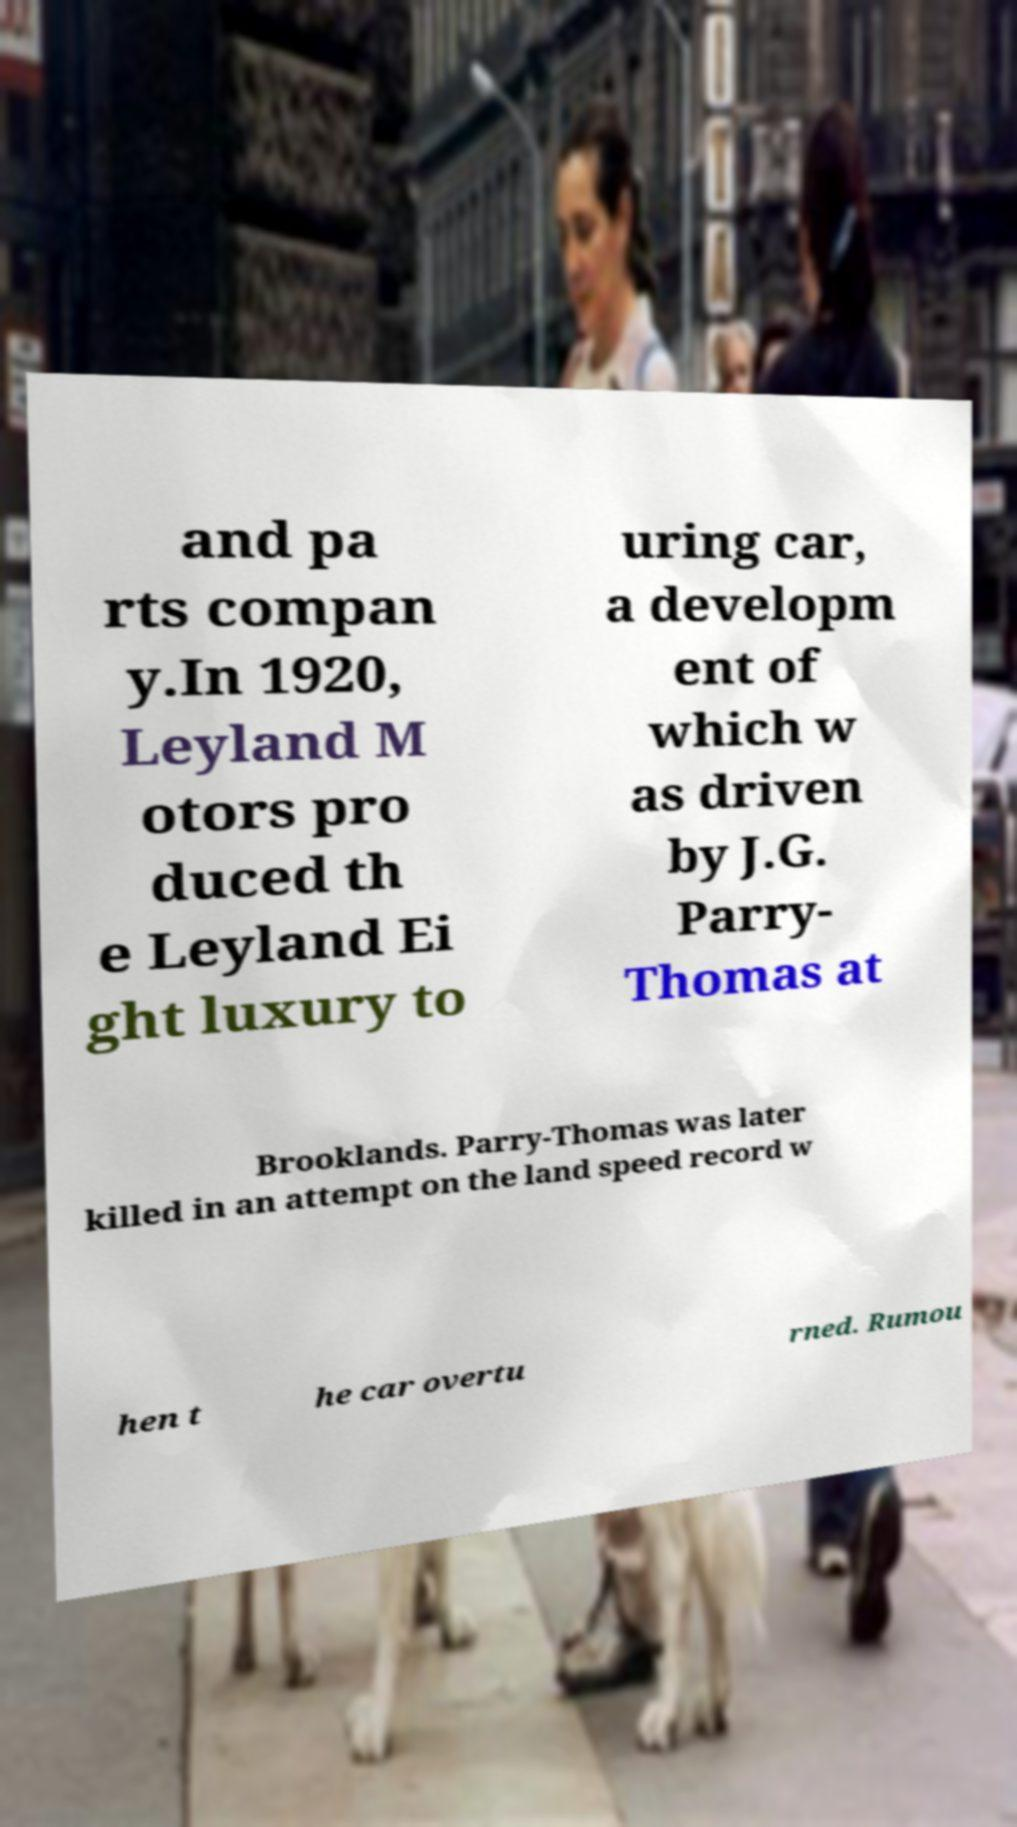Can you accurately transcribe the text from the provided image for me? and pa rts compan y.In 1920, Leyland M otors pro duced th e Leyland Ei ght luxury to uring car, a developm ent of which w as driven by J.G. Parry- Thomas at Brooklands. Parry-Thomas was later killed in an attempt on the land speed record w hen t he car overtu rned. Rumou 